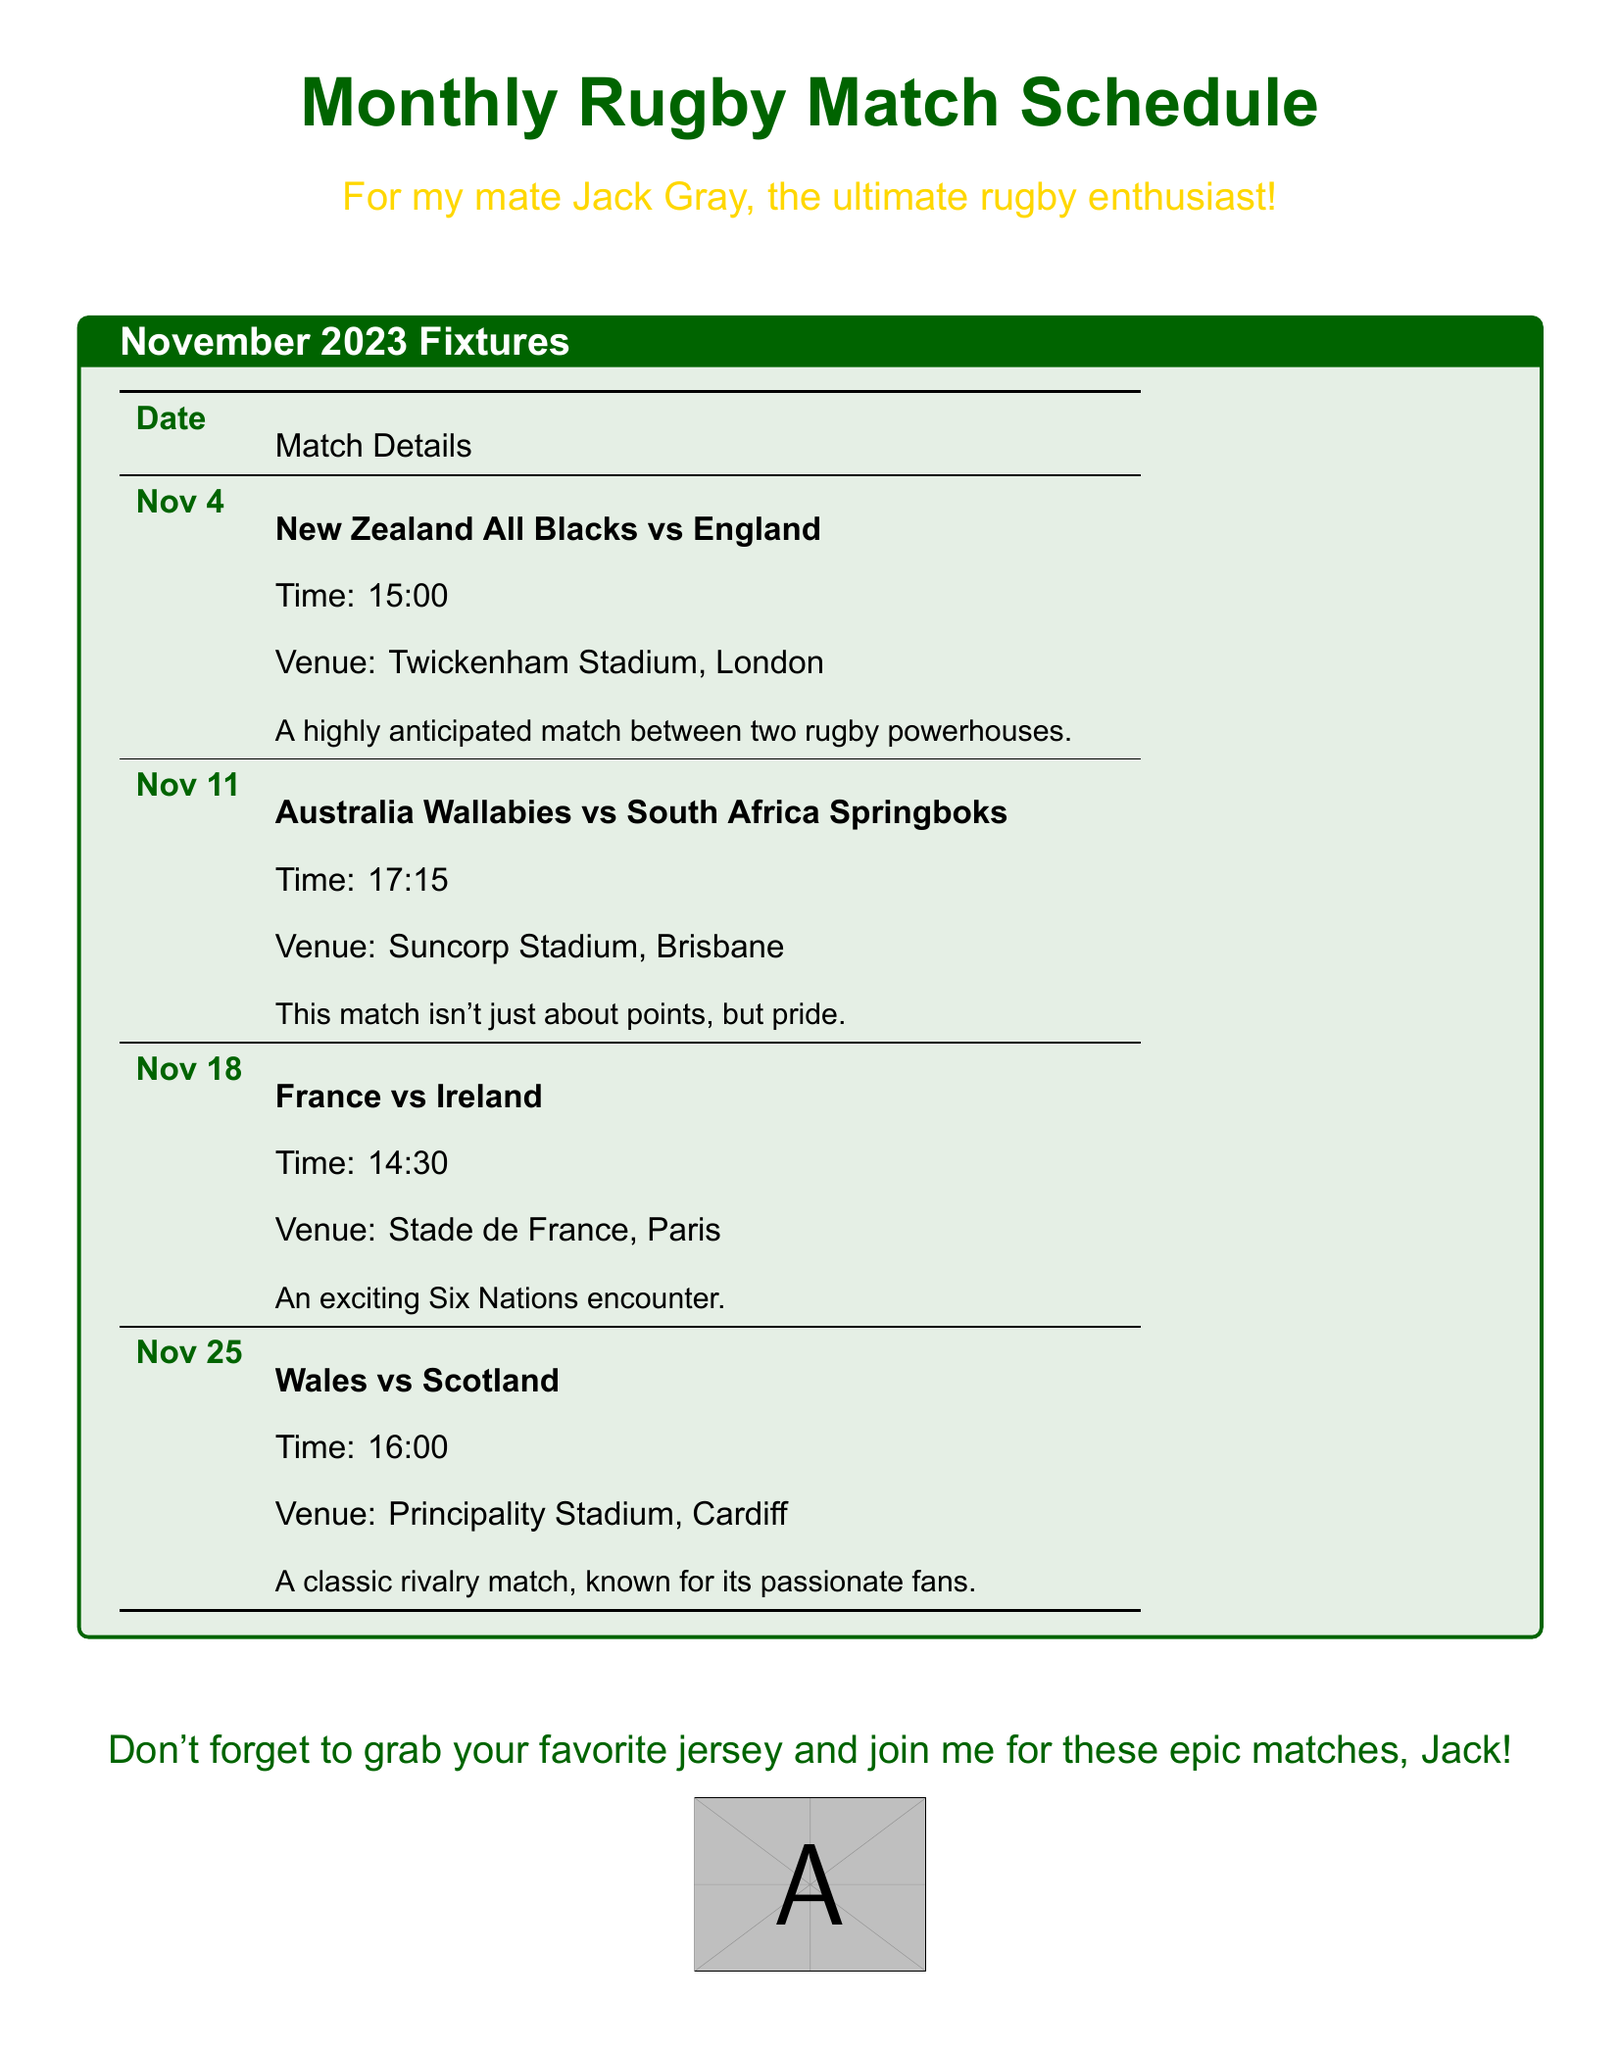What is the date of the match between New Zealand All Blacks and England? The date is mentioned specifically in the match details for New Zealand All Blacks vs England.
Answer: Nov 4 What is the venue for the match between Australia Wallabies and South Africa Springboks? The venue is outlined within the match details for the Australia Wallabies vs South Africa Springboks game.
Answer: Suncorp Stadium, Brisbane What time does the France vs Ireland match start? The start time is clearly listed in the match details for the France vs Ireland encounter.
Answer: 14:30 How many matches are scheduled for November 2023? The total number of matches can be counted from the fixture list in the document.
Answer: 4 Which teams are involved in a classic rivalry match? This information is specified in the match details for the Wales vs Scotland game.
Answer: Wales vs Scotland What color is used for the document's title? The color of the title text is specified and is visually identifiable in the document.
Answer: rugbygreen What is the time for the match on November 11? The time is explicitly stated in the match details for the Australia Wallabies vs South Africa Springboks game.
Answer: 17:15 Which stadium will host the match on November 25? The venue is detailed for the match between Wales and Scotland in the document.
Answer: Principality Stadium, Cardiff What special event is highlighted for the match on November 18? The match details provide insight into the nature of the match between France and Ireland.
Answer: Six Nations encounter 